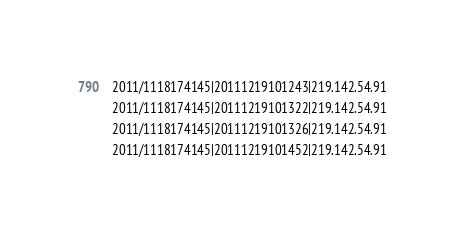<code> <loc_0><loc_0><loc_500><loc_500><_HTML_>2011/1118174145|20111219101243|219.142.54.91
2011/1118174145|20111219101322|219.142.54.91
2011/1118174145|20111219101326|219.142.54.91
2011/1118174145|20111219101452|219.142.54.91
</code> 